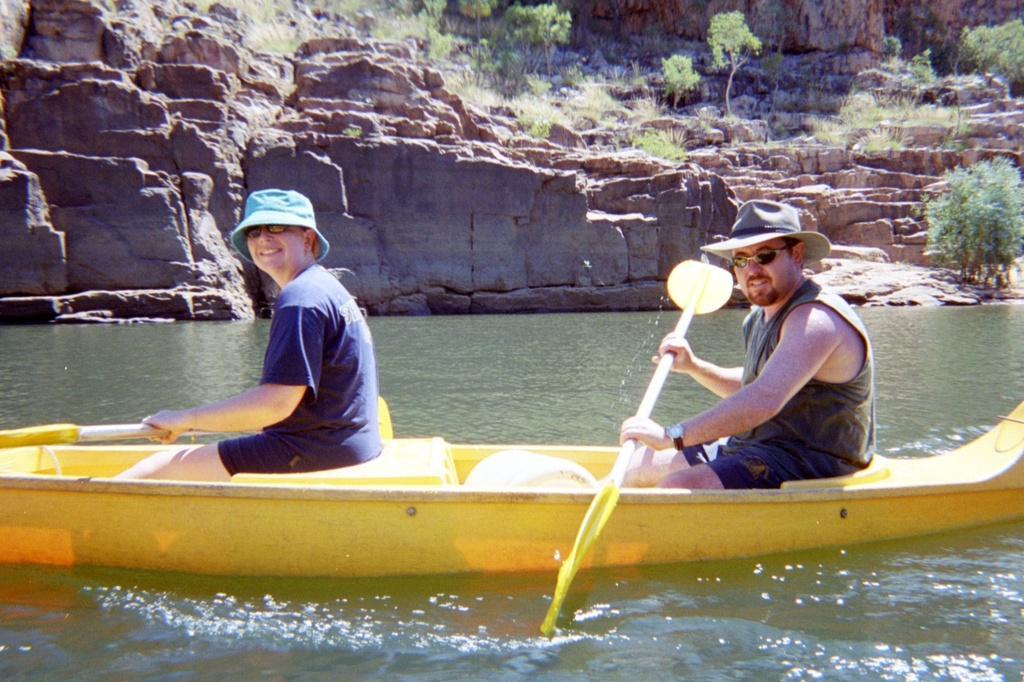Can you describe this image briefly? In this image I can see water and in it I can see a yellow colour boat. I can also see two persons are sitting and I can see both of them are holding paddles. I can see both of them are wearing shades and hats. In the background I can see grass and few trees. 